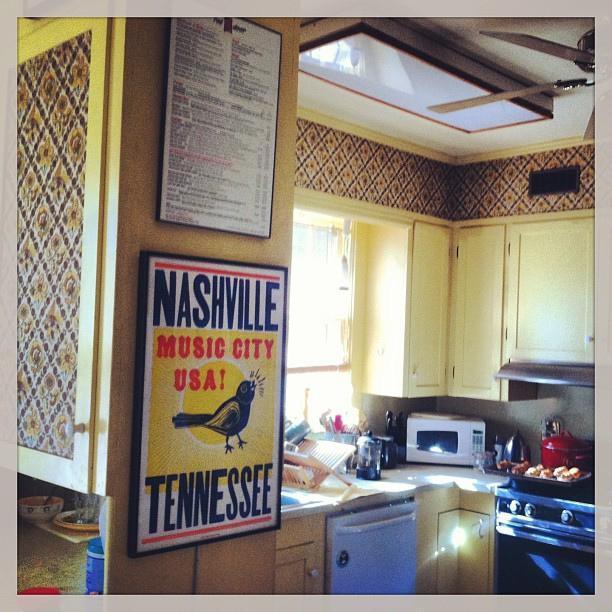How many air vents are there?
Give a very brief answer. 1. How many square lights are on the ceiling?
Give a very brief answer. 1. 